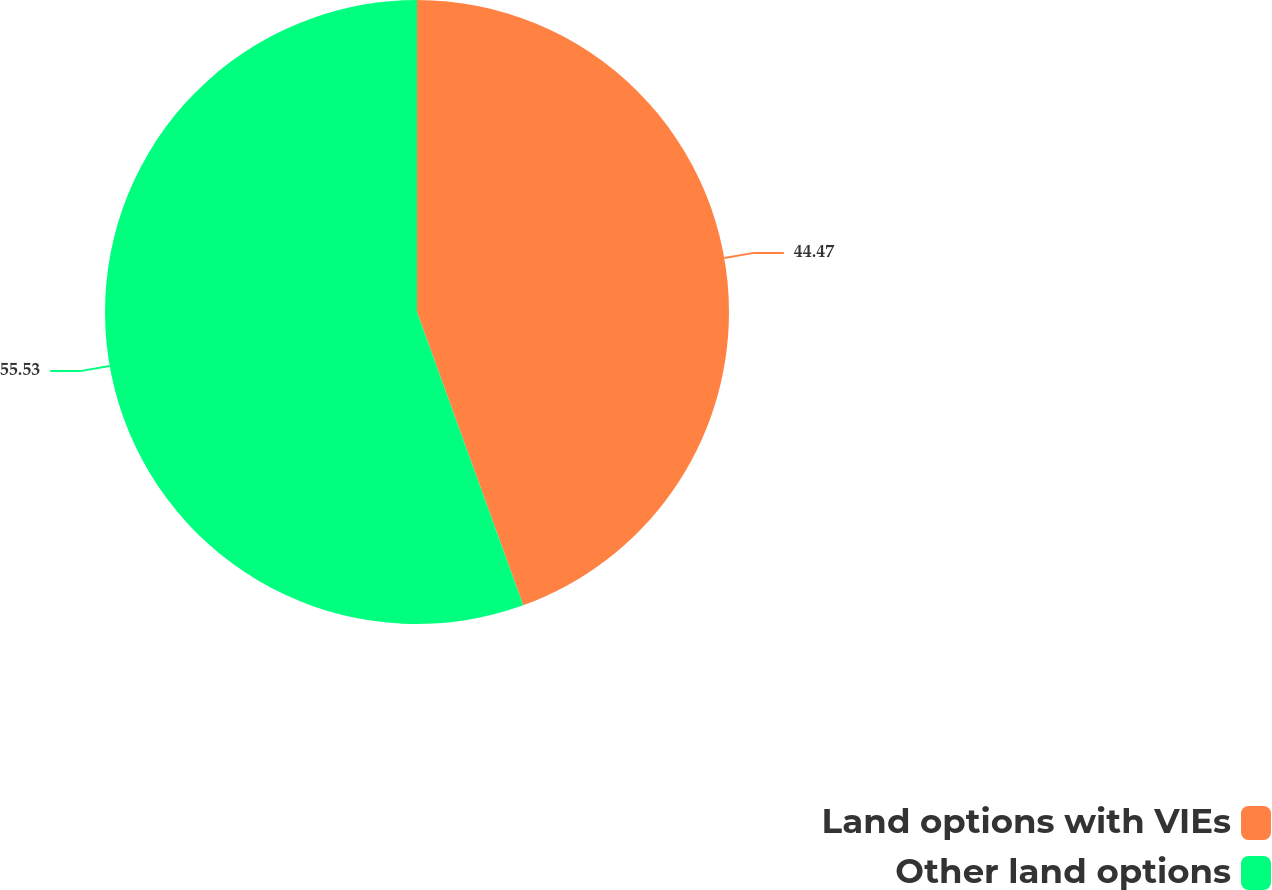Convert chart. <chart><loc_0><loc_0><loc_500><loc_500><pie_chart><fcel>Land options with VIEs<fcel>Other land options<nl><fcel>44.47%<fcel>55.53%<nl></chart> 